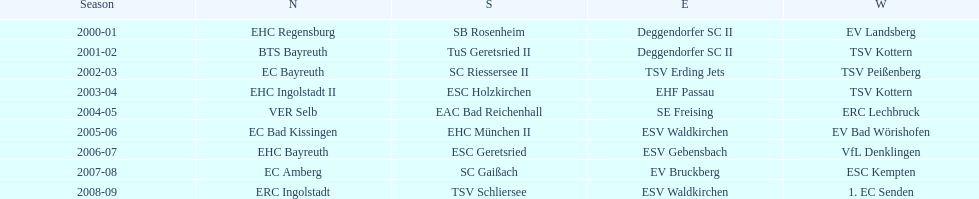Starting with the 2007 - 08 season, does ecs kempten appear in any of the previous years? No. 